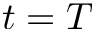<formula> <loc_0><loc_0><loc_500><loc_500>t = T</formula> 